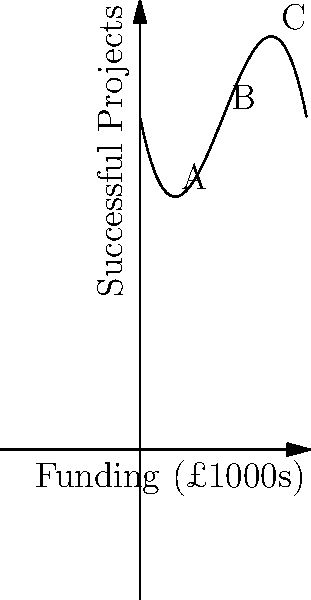The graph represents a polynomial regression model of the relationship between funding and successful mission projects in the UK. Given the curve's shape, which point (A, B, or C) likely represents the optimal funding level for maximizing successful projects, and why might this be significant for mission work strategy? To answer this question, we need to analyze the graph and understand the relationship it represents:

1. The x-axis represents funding in thousands of pounds, while the y-axis represents the number of successful projects.

2. The curve is a cubic polynomial, showing a complex relationship between funding and project success.

3. Point A (around £2,000 funding) shows a low number of successful projects, likely due to insufficient resources.

4. Point B (around £5,000 funding) appears to be at or near the peak of the curve, representing the highest number of successful projects.

5. Point C (around £8,000 funding) shows a decline in successful projects despite increased funding, possibly due to diminishing returns or overextension.

6. The optimal funding level would be at the peak of the curve, which maximizes the number of successful projects for the given funding.

7. This point is closest to B on the graph.

8. For mission work strategy, this is significant because:
   a) It suggests there's an optimal level of funding for mission projects.
   b) Increasing funding beyond this point may not lead to more successful projects.
   c) It emphasizes the importance of efficient resource allocation in mission work.
Answer: Point B; represents optimal funding for maximum project success, crucial for efficient resource allocation in mission work. 